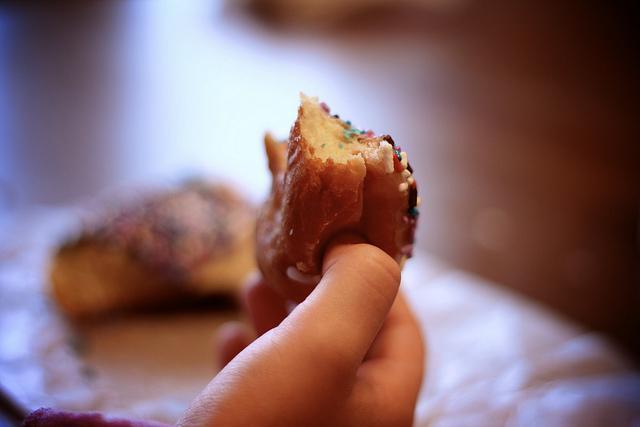How many donuts are in the picture?
Give a very brief answer. 2. How many of the cows in this picture are chocolate brown?
Give a very brief answer. 0. 